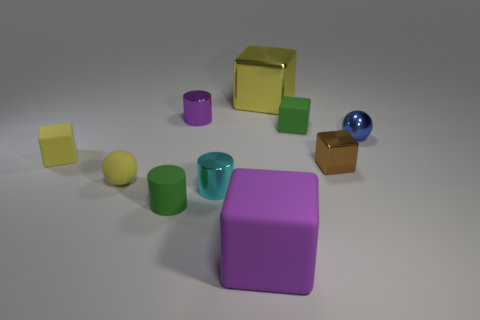If these objects were part of a game, what kind of game could it be? Considering the variety of shapes and colors, these objects might be used in a sorting or matching game where players could sort them by color, shape, or size. Alternatively, it could be a construction game where the objects are used to build various structures according to a set of rules or challenges. 